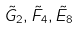Convert formula to latex. <formula><loc_0><loc_0><loc_500><loc_500>\tilde { G } _ { 2 } , \tilde { F } _ { 4 } , \tilde { E } _ { 8 }</formula> 